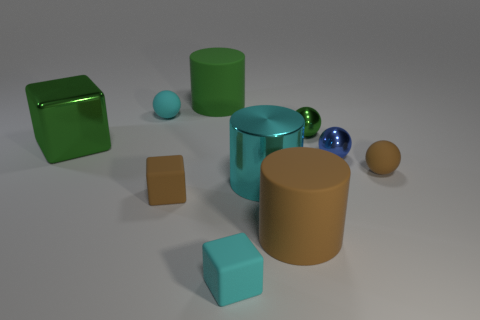Can you describe the colors in the image? Certainly! The image presents a variety of colors: there is a green cube, a turquoise square prism, a brown cylinder, a shiny teal cylinder, a small blue sphere, and a tan sphere. There's a presence of reflections and lighting that add depth to each object's color. 